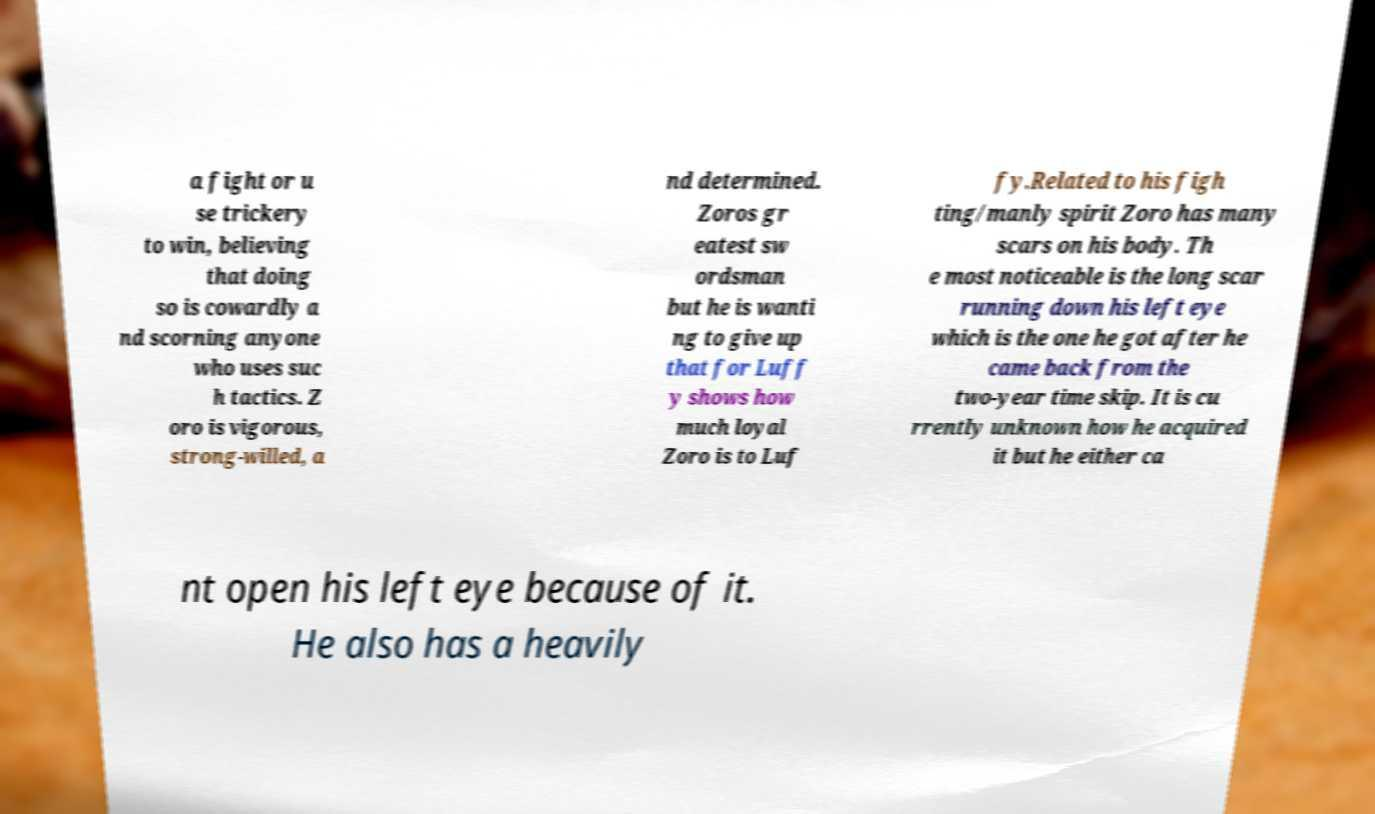What messages or text are displayed in this image? I need them in a readable, typed format. a fight or u se trickery to win, believing that doing so is cowardly a nd scorning anyone who uses suc h tactics. Z oro is vigorous, strong-willed, a nd determined. Zoros gr eatest sw ordsman but he is wanti ng to give up that for Luff y shows how much loyal Zoro is to Luf fy.Related to his figh ting/manly spirit Zoro has many scars on his body. Th e most noticeable is the long scar running down his left eye which is the one he got after he came back from the two-year time skip. It is cu rrently unknown how he acquired it but he either ca nt open his left eye because of it. He also has a heavily 